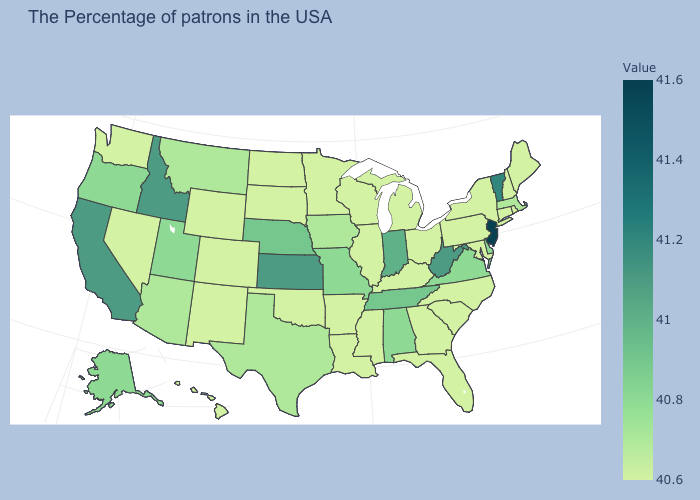Does West Virginia have the highest value in the South?
Quick response, please. Yes. Which states hav the highest value in the MidWest?
Write a very short answer. Kansas. Does Utah have the lowest value in the West?
Concise answer only. No. Does Delaware have a lower value than Indiana?
Give a very brief answer. Yes. Does Alabama have a lower value than Indiana?
Short answer required. Yes. Among the states that border New Hampshire , which have the lowest value?
Keep it brief. Maine. 